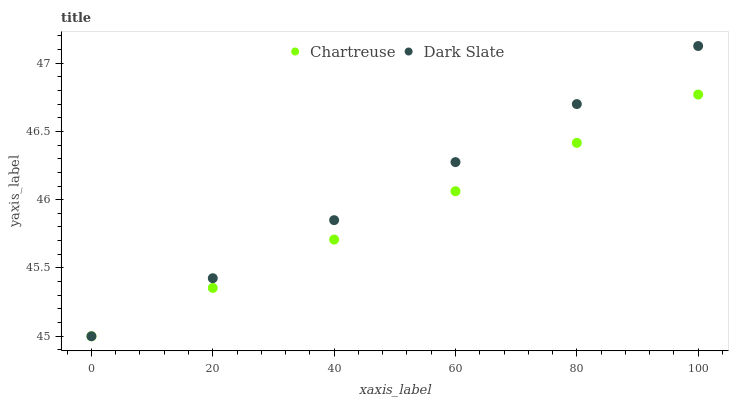Does Chartreuse have the minimum area under the curve?
Answer yes or no. Yes. Does Dark Slate have the maximum area under the curve?
Answer yes or no. Yes. Does Chartreuse have the maximum area under the curve?
Answer yes or no. No. Is Chartreuse the smoothest?
Answer yes or no. Yes. Is Dark Slate the roughest?
Answer yes or no. Yes. Is Chartreuse the roughest?
Answer yes or no. No. Does Dark Slate have the lowest value?
Answer yes or no. Yes. Does Dark Slate have the highest value?
Answer yes or no. Yes. Does Chartreuse have the highest value?
Answer yes or no. No. Does Dark Slate intersect Chartreuse?
Answer yes or no. Yes. Is Dark Slate less than Chartreuse?
Answer yes or no. No. Is Dark Slate greater than Chartreuse?
Answer yes or no. No. 